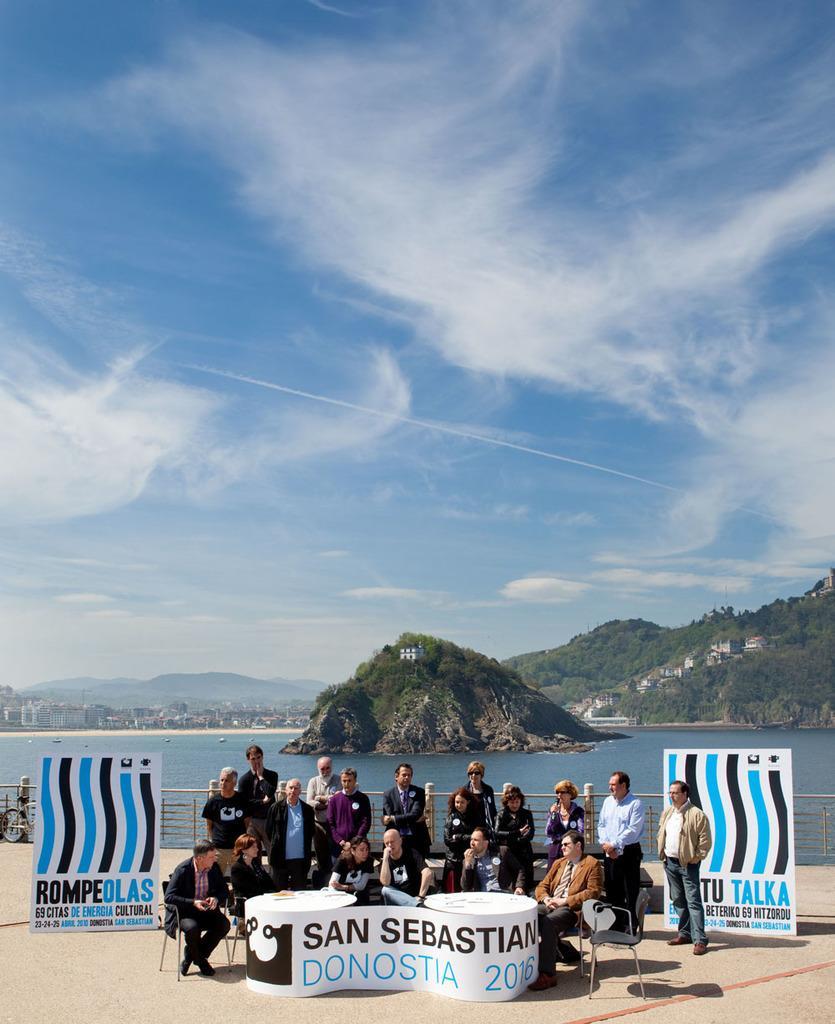Can you describe this image briefly? In this image few persons are sitting on the chair before a table. there are few persons standing on the floor. There are two banners and a bicycle are on the floor. Behind there is a fence. There is a hill on water. Left side there are few buildings. Behind it there are few hills. Top of image there is sky with some clouds. Right side there are few houses on hill having few trees. 